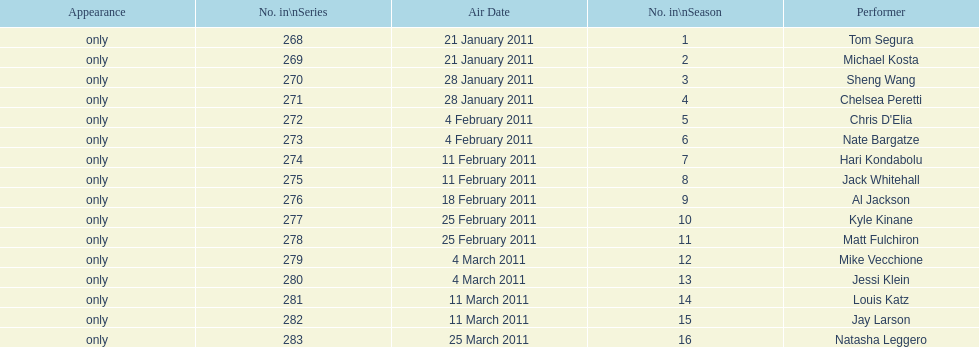Would you mind parsing the complete table? {'header': ['Appearance', 'No. in\\nSeries', 'Air Date', 'No. in\\nSeason', 'Performer'], 'rows': [['only', '268', '21 January 2011', '1', 'Tom Segura'], ['only', '269', '21 January 2011', '2', 'Michael Kosta'], ['only', '270', '28 January 2011', '3', 'Sheng Wang'], ['only', '271', '28 January 2011', '4', 'Chelsea Peretti'], ['only', '272', '4 February 2011', '5', "Chris D'Elia"], ['only', '273', '4 February 2011', '6', 'Nate Bargatze'], ['only', '274', '11 February 2011', '7', 'Hari Kondabolu'], ['only', '275', '11 February 2011', '8', 'Jack Whitehall'], ['only', '276', '18 February 2011', '9', 'Al Jackson'], ['only', '277', '25 February 2011', '10', 'Kyle Kinane'], ['only', '278', '25 February 2011', '11', 'Matt Fulchiron'], ['only', '279', '4 March 2011', '12', 'Mike Vecchione'], ['only', '280', '4 March 2011', '13', 'Jessi Klein'], ['only', '281', '11 March 2011', '14', 'Louis Katz'], ['only', '282', '11 March 2011', '15', 'Jay Larson'], ['only', '283', '25 March 2011', '16', 'Natasha Leggero']]} How many episodes only had one performer? 16. 